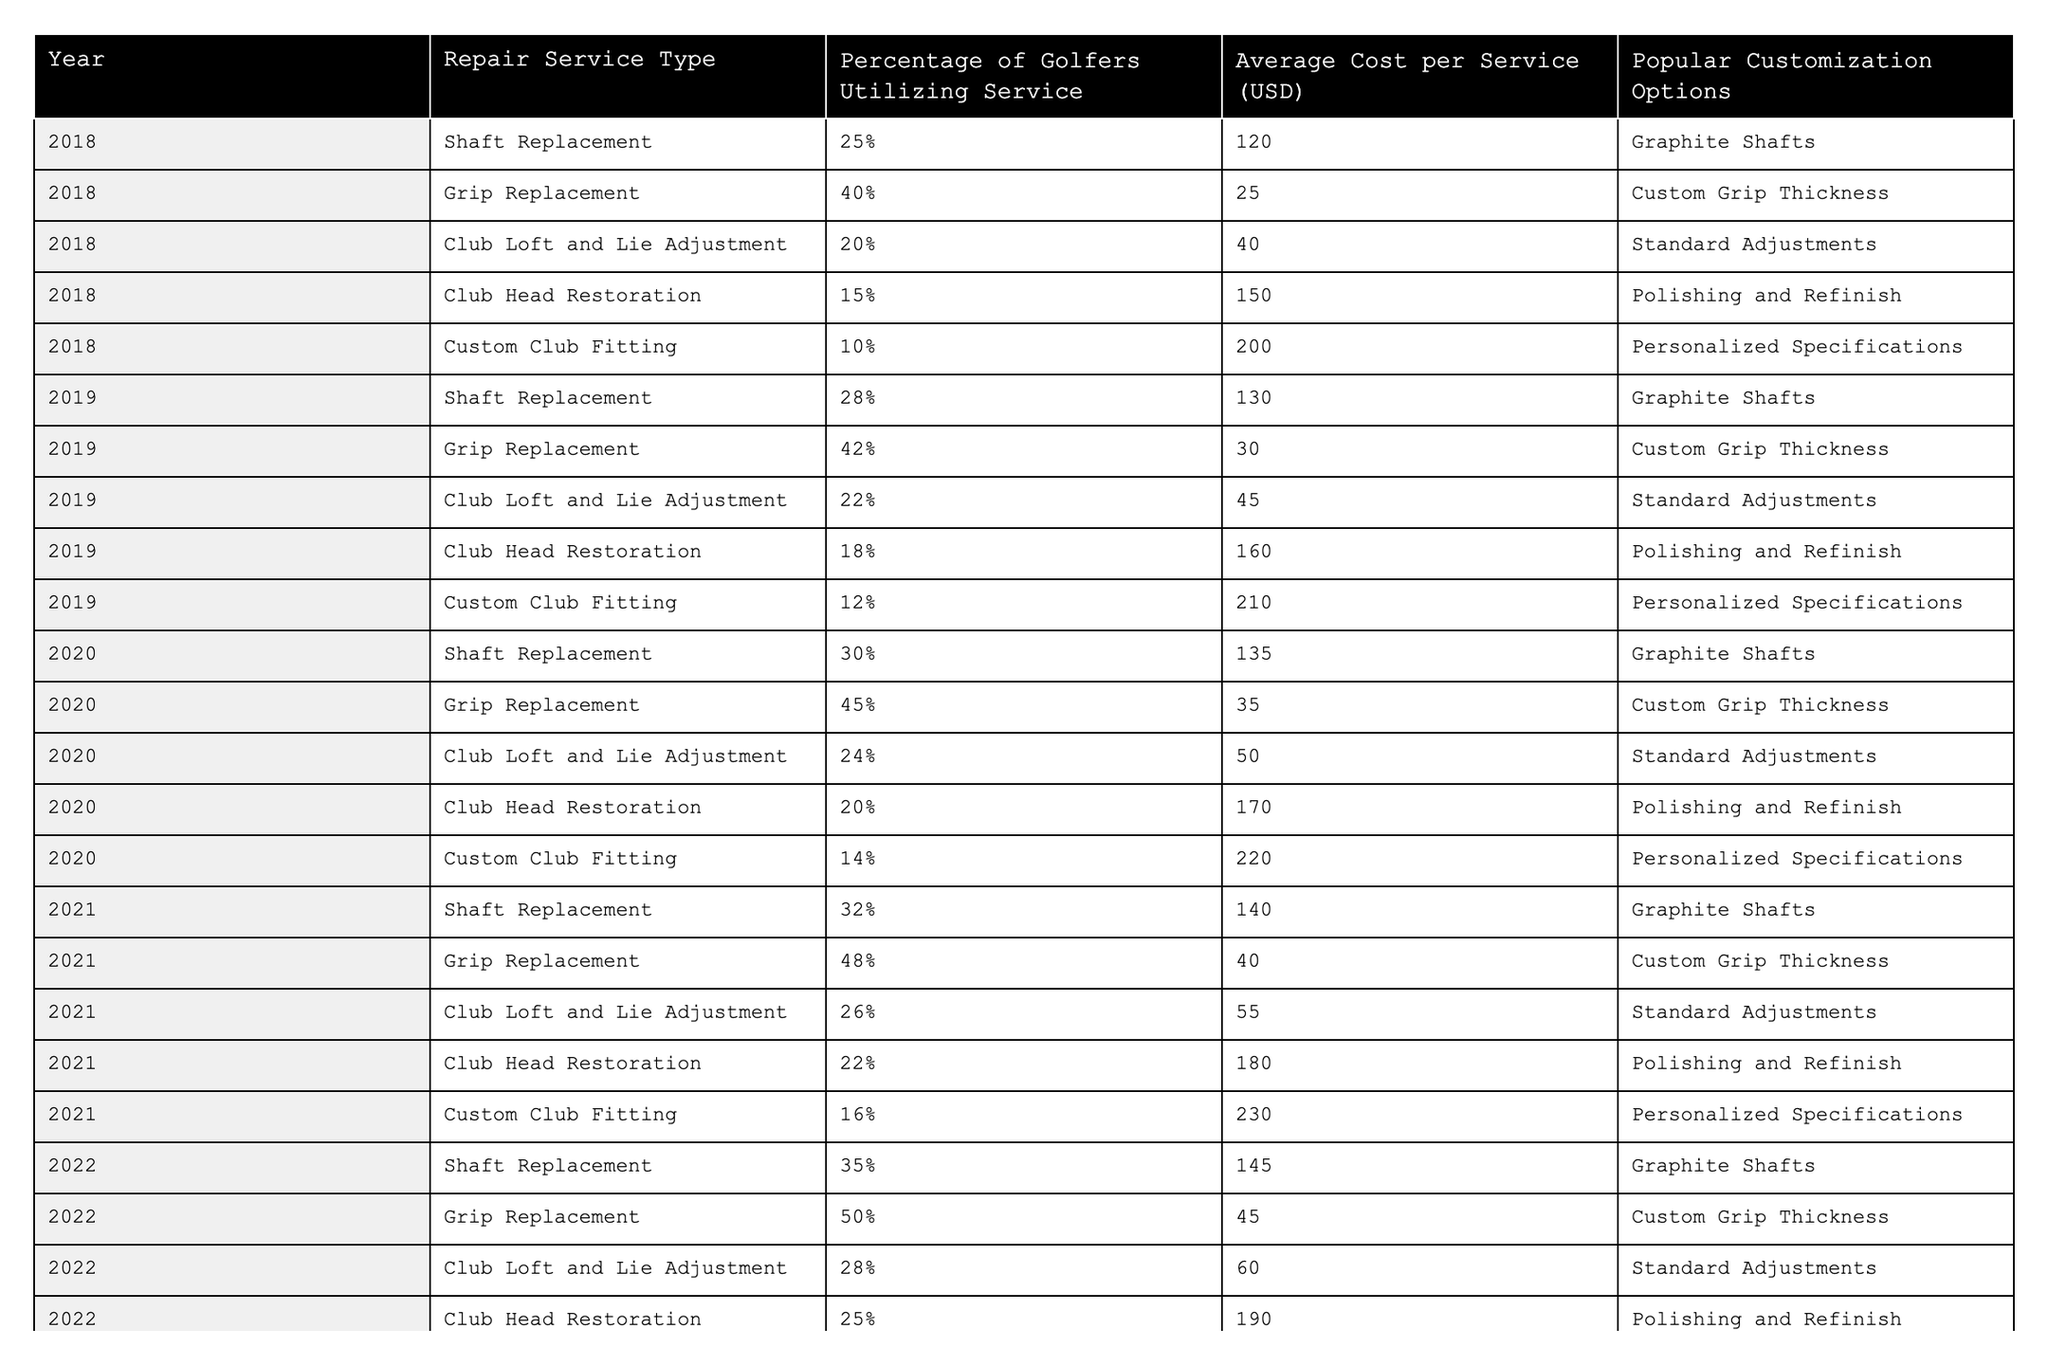What was the most utilized repair service in 2022? In 2022, the grip replacement service had the highest percentage of golfers utilizing the service at 50%.
Answer: Grip Replacement Which year had the highest average cost for custom club fitting? The average cost for custom club fitting increased each year, and in 2023 it reached 250 USD, which is higher than any other year.
Answer: 2023 What percentage of golfers utilized shaft replacement services in 2019? The table shows that in 2019, 28% of golfers utilized shaft replacement services.
Answer: 28% What is the difference in average cost of club head restoration between 2018 and 2023? The average cost for club head restoration in 2018 was 150 USD, and in 2023 it increased to 200 USD. The difference is calculated as 200 - 150 = 50 USD.
Answer: 50 USD Did the percentage of golfers utilizing club loft and lie adjustment services increase every year from 2018 to 2023? Looking at the table, the percentage of golfers utilizing club loft and lie adjustment services increased each year, from 20% in 2018 to 30% in 2023.
Answer: Yes What was the total percentage of golfers utilizing club head restoration services over the entire period? The total percentage is the sum of the percentages for each year: 15% (2018) + 18% (2019) + 20% (2020) + 22% (2021) + 25% (2022) + 27% (2023) = 127%.
Answer: 127% What popular customization option has remained consistent for the shaft replacement service across all years? The popular customization option for shaft replacement has consistently been graphite shafts from 2018 to 2023.
Answer: Graphite Shafts In which year did grip replacement see the highest percentage of utilization, and what was that percentage? Grip replacement saw the highest percentage of utilization in 2022, at 50%.
Answer: 2022, 50% How much did the average cost for grip replacement increase from 2018 to 2023? The average cost for grip replacement was 25 USD in 2018 and increased to 50 USD in 2023, resulting in an increase of 50 - 25 = 25 USD.
Answer: 25 USD What year had the most significant increase in golfers utilizing custom club fitting services? The largest increase in golfers utilizing custom club fitting happened between 2021 (16%) and 2022 (18%), which is 2 percentage points; hence, 2022 had significant growth, though consistently increasing from 2018 to 2023.
Answer: 2022 